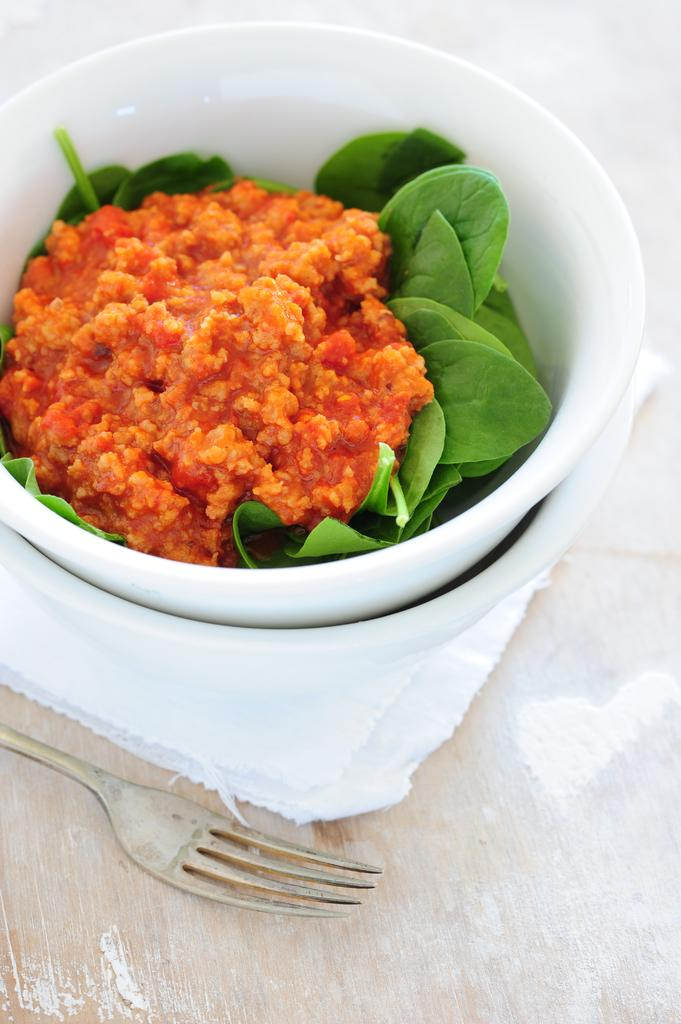What is placed on the leaves in the bowl? There is food on the leaves in a bowl. What is the bowl resting on? The bowl is on a cloth. What is the cloth placed on? The cloth is on a wooden surface. What utensil is near the bowl? There is a fork beside the bowl. What type of hair can be seen on the leaves in the image? There is no hair present on the leaves in the image; it is food. 